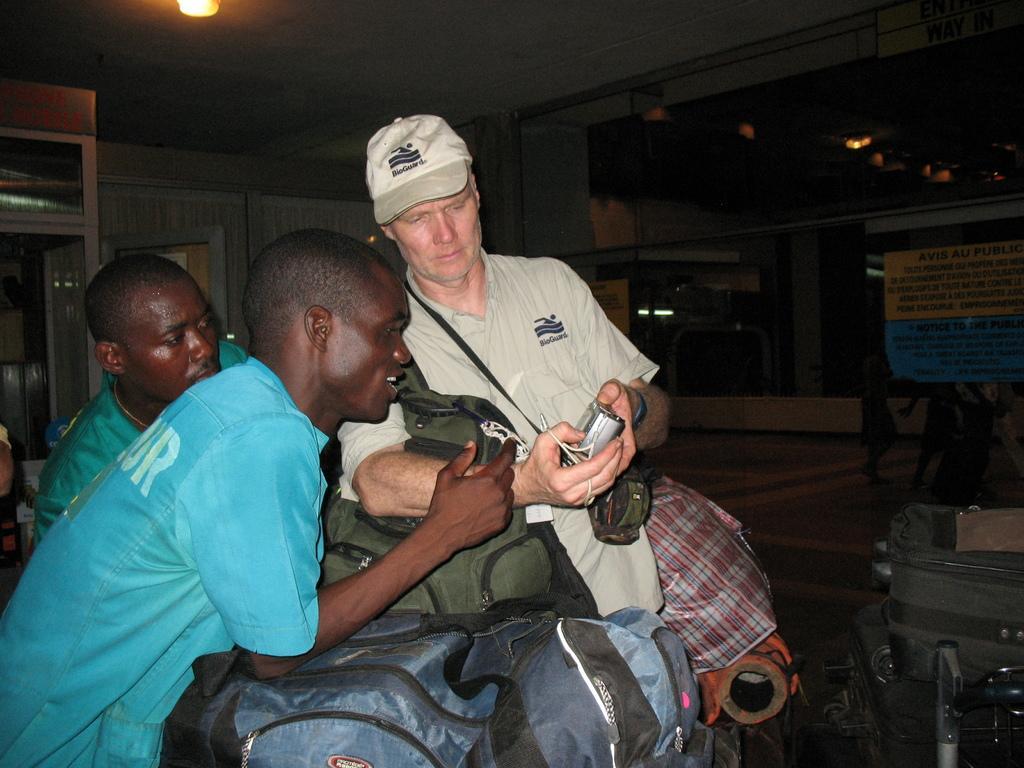Could you give a brief overview of what you see in this image? In this picture we can see lights, broads, people, bags, floor and objects. We can see people staring at a camera. We can see a man wearing a cap and holding a camera. 